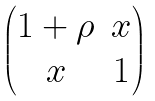<formula> <loc_0><loc_0><loc_500><loc_500>\begin{pmatrix} 1 + \rho & x \\ x & 1 \end{pmatrix}</formula> 